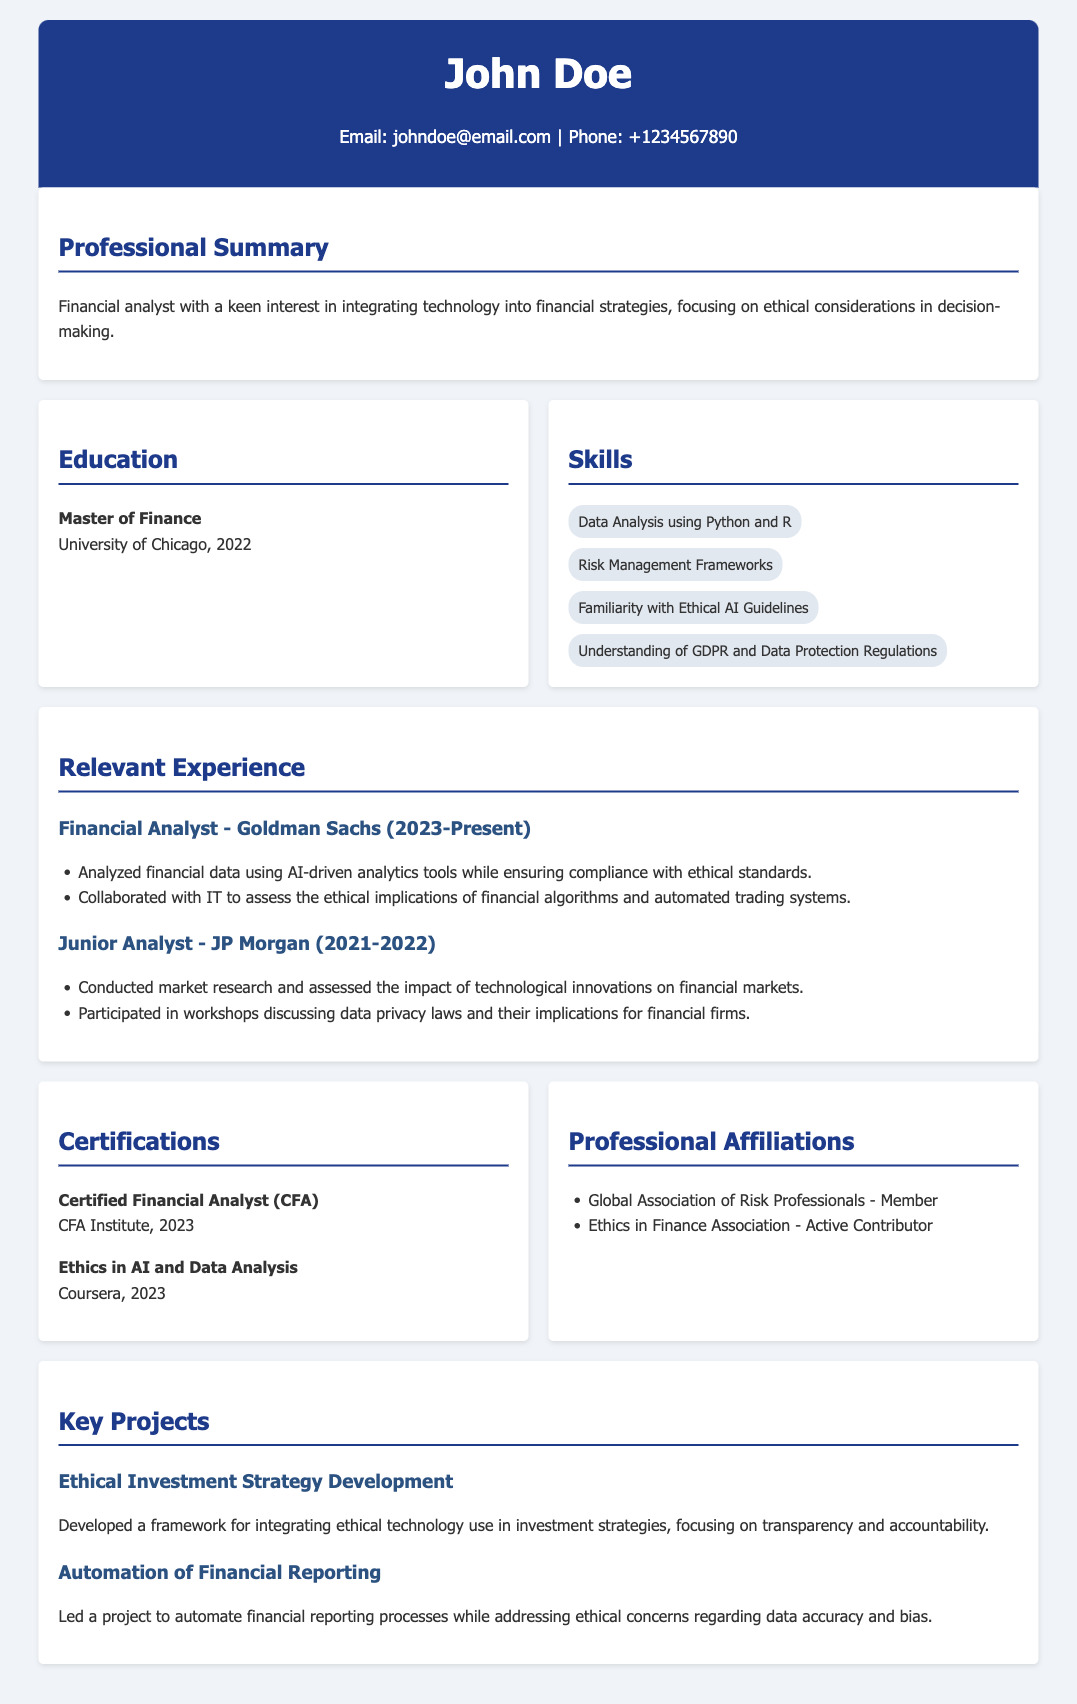What is the name of the financial analyst? The document identifies the financial analyst as John Doe.
Answer: John Doe What degree did John Doe earn? According to the education section, John Doe earned a Master of Finance.
Answer: Master of Finance Which organization is John Doe currently employed with? The document states that John Doe is currently a financial analyst at Goldman Sachs.
Answer: Goldman Sachs In which year did John Doe complete the CFA certification? The CFA certification year mentioned in the document is 2023.
Answer: 2023 What ethical aspect does John Doe focus on in his work? John Doe focuses on ethical considerations in financial decision-making as indicated in the professional summary.
Answer: Ethical considerations What was one responsibility of John Doe at Goldman Sachs? The document notes that one of John Doe's responsibilities was analyzing financial data using AI-driven analytics tools while ensuring compliance with ethical standards.
Answer: Analyzing financial data Name one project led by John Doe related to ethical concerns. The document mentions that John Doe led a project on the automation of financial reporting processes while addressing ethical concerns.
Answer: Automation of Financial Reporting Which professional association is John Doe an active contributor to? The document lists the Ethics in Finance Association as one of the associations John Doe actively contributes to.
Answer: Ethics in Finance Association What skill related to technology does John Doe possess? The skills section indicates that John Doe has familiarity with ethical AI guidelines as a relevant skill.
Answer: Ethical AI Guidelines 